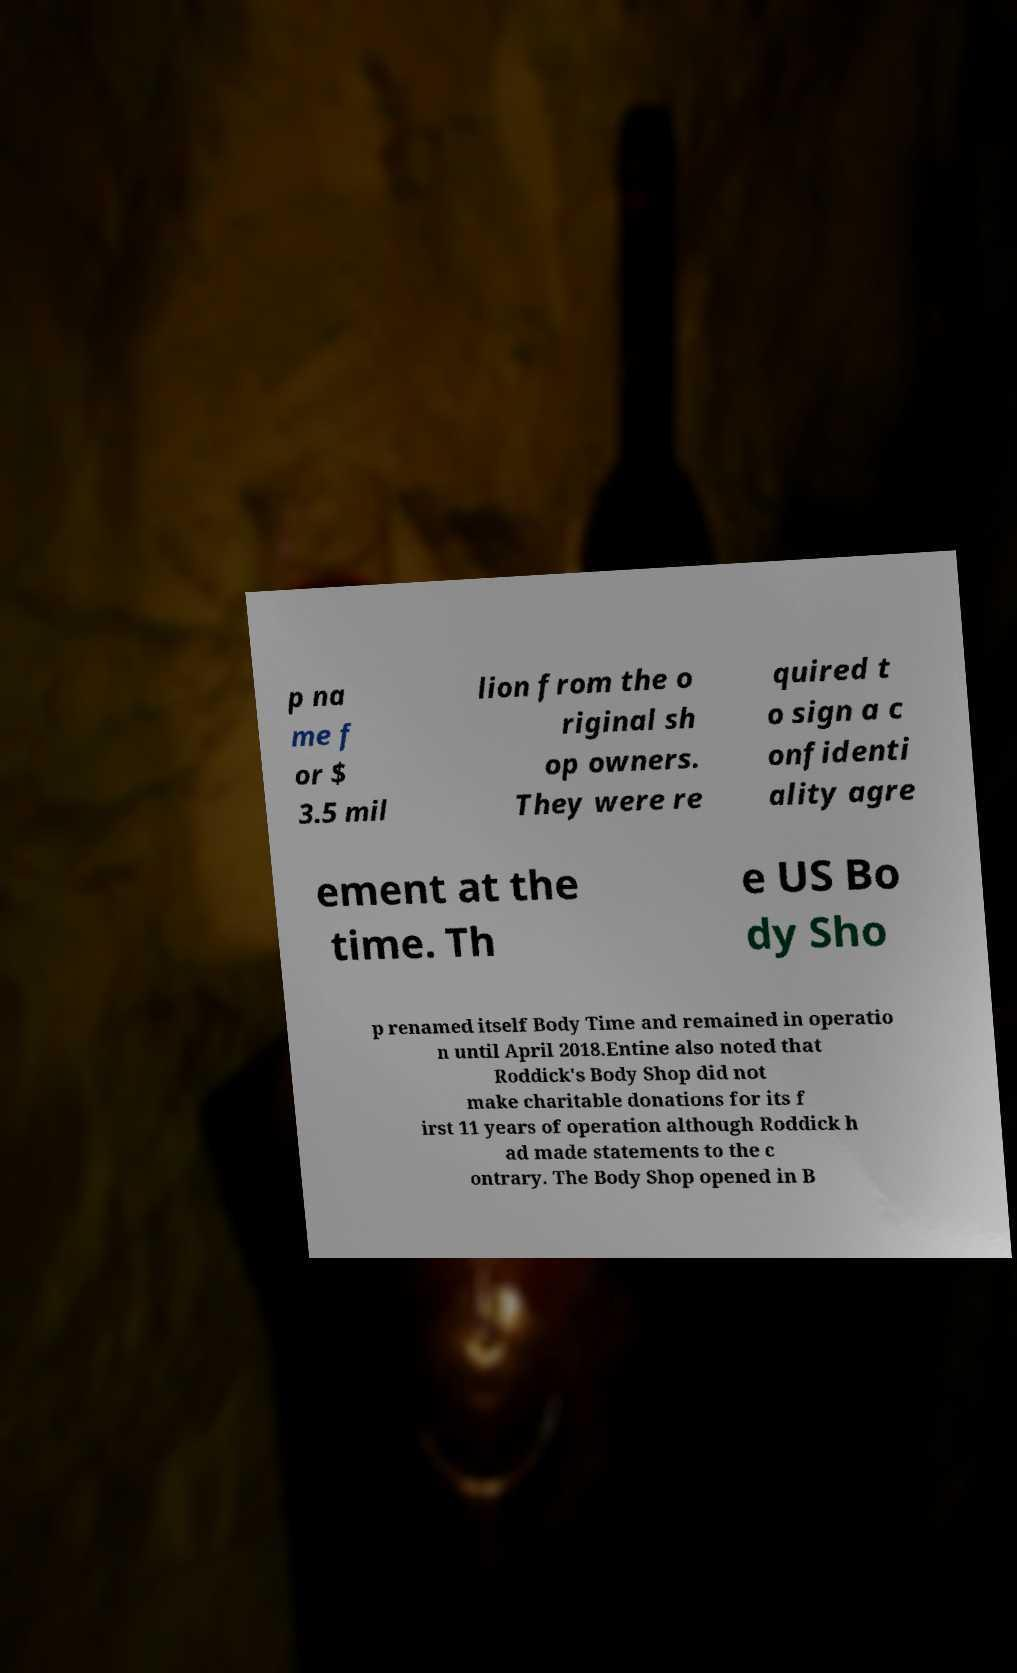Could you extract and type out the text from this image? p na me f or $ 3.5 mil lion from the o riginal sh op owners. They were re quired t o sign a c onfidenti ality agre ement at the time. Th e US Bo dy Sho p renamed itself Body Time and remained in operatio n until April 2018.Entine also noted that Roddick's Body Shop did not make charitable donations for its f irst 11 years of operation although Roddick h ad made statements to the c ontrary. The Body Shop opened in B 